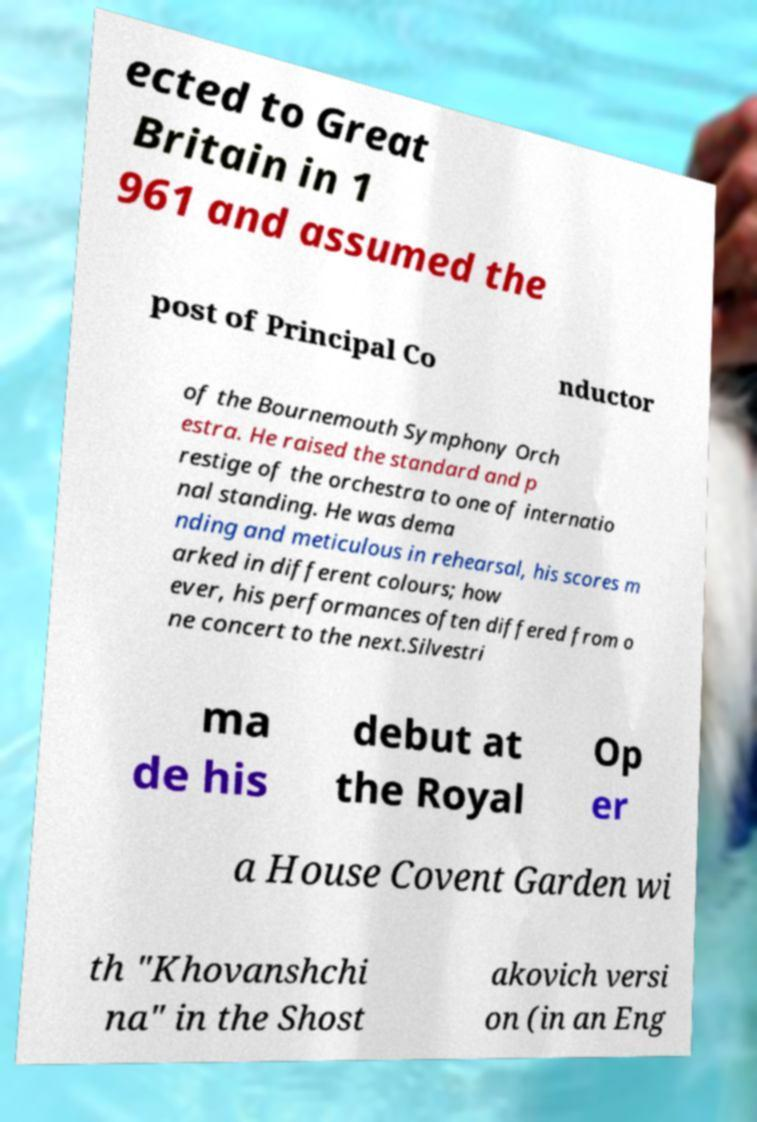Could you assist in decoding the text presented in this image and type it out clearly? ected to Great Britain in 1 961 and assumed the post of Principal Co nductor of the Bournemouth Symphony Orch estra. He raised the standard and p restige of the orchestra to one of internatio nal standing. He was dema nding and meticulous in rehearsal, his scores m arked in different colours; how ever, his performances often differed from o ne concert to the next.Silvestri ma de his debut at the Royal Op er a House Covent Garden wi th "Khovanshchi na" in the Shost akovich versi on (in an Eng 